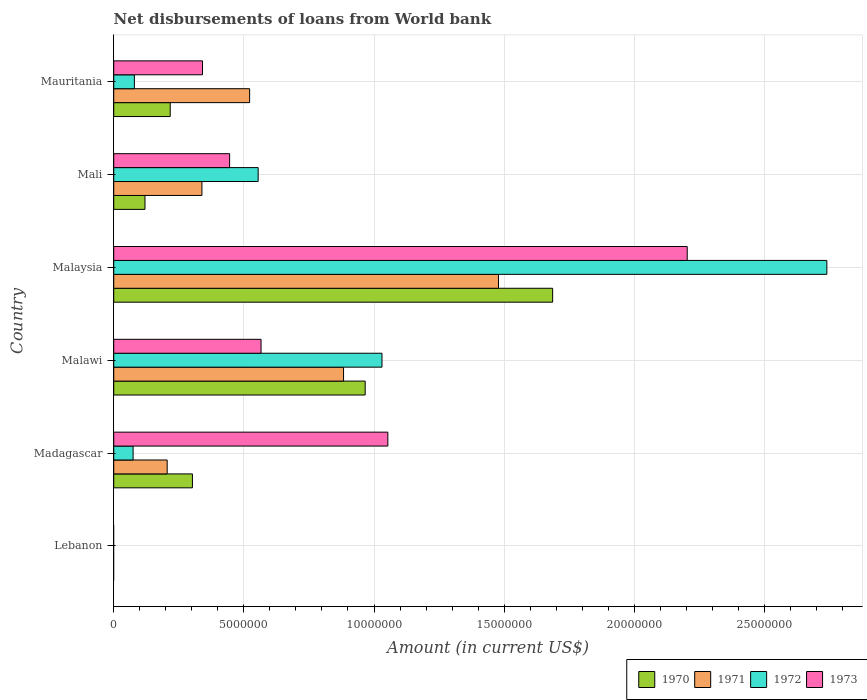How many different coloured bars are there?
Your answer should be compact. 4. What is the label of the 4th group of bars from the top?
Your response must be concise. Malawi. In how many cases, is the number of bars for a given country not equal to the number of legend labels?
Keep it short and to the point. 1. What is the amount of loan disbursed from World Bank in 1970 in Malaysia?
Make the answer very short. 1.69e+07. Across all countries, what is the maximum amount of loan disbursed from World Bank in 1972?
Give a very brief answer. 2.74e+07. In which country was the amount of loan disbursed from World Bank in 1973 maximum?
Give a very brief answer. Malaysia. What is the total amount of loan disbursed from World Bank in 1972 in the graph?
Give a very brief answer. 4.48e+07. What is the difference between the amount of loan disbursed from World Bank in 1971 in Malaysia and that in Mali?
Ensure brevity in your answer.  1.14e+07. What is the difference between the amount of loan disbursed from World Bank in 1973 in Malaysia and the amount of loan disbursed from World Bank in 1972 in Madagascar?
Offer a terse response. 2.13e+07. What is the average amount of loan disbursed from World Bank in 1971 per country?
Offer a very short reply. 5.71e+06. What is the difference between the amount of loan disbursed from World Bank in 1971 and amount of loan disbursed from World Bank in 1970 in Madagascar?
Make the answer very short. -9.70e+05. In how many countries, is the amount of loan disbursed from World Bank in 1973 greater than 4000000 US$?
Ensure brevity in your answer.  4. What is the ratio of the amount of loan disbursed from World Bank in 1970 in Malaysia to that in Mauritania?
Give a very brief answer. 7.77. Is the difference between the amount of loan disbursed from World Bank in 1971 in Madagascar and Mali greater than the difference between the amount of loan disbursed from World Bank in 1970 in Madagascar and Mali?
Give a very brief answer. No. What is the difference between the highest and the second highest amount of loan disbursed from World Bank in 1973?
Provide a succinct answer. 1.15e+07. What is the difference between the highest and the lowest amount of loan disbursed from World Bank in 1972?
Offer a terse response. 2.74e+07. Is it the case that in every country, the sum of the amount of loan disbursed from World Bank in 1970 and amount of loan disbursed from World Bank in 1971 is greater than the sum of amount of loan disbursed from World Bank in 1972 and amount of loan disbursed from World Bank in 1973?
Your response must be concise. No. What is the difference between two consecutive major ticks on the X-axis?
Your answer should be compact. 5.00e+06. Are the values on the major ticks of X-axis written in scientific E-notation?
Keep it short and to the point. No. How are the legend labels stacked?
Provide a succinct answer. Horizontal. What is the title of the graph?
Make the answer very short. Net disbursements of loans from World bank. What is the label or title of the X-axis?
Your answer should be very brief. Amount (in current US$). What is the Amount (in current US$) of 1971 in Lebanon?
Your answer should be compact. 0. What is the Amount (in current US$) of 1970 in Madagascar?
Provide a short and direct response. 3.02e+06. What is the Amount (in current US$) in 1971 in Madagascar?
Ensure brevity in your answer.  2.05e+06. What is the Amount (in current US$) in 1972 in Madagascar?
Offer a terse response. 7.44e+05. What is the Amount (in current US$) of 1973 in Madagascar?
Provide a short and direct response. 1.05e+07. What is the Amount (in current US$) of 1970 in Malawi?
Ensure brevity in your answer.  9.66e+06. What is the Amount (in current US$) of 1971 in Malawi?
Offer a terse response. 8.83e+06. What is the Amount (in current US$) of 1972 in Malawi?
Offer a very short reply. 1.03e+07. What is the Amount (in current US$) of 1973 in Malawi?
Keep it short and to the point. 5.66e+06. What is the Amount (in current US$) in 1970 in Malaysia?
Provide a short and direct response. 1.69e+07. What is the Amount (in current US$) of 1971 in Malaysia?
Keep it short and to the point. 1.48e+07. What is the Amount (in current US$) of 1972 in Malaysia?
Keep it short and to the point. 2.74e+07. What is the Amount (in current US$) of 1973 in Malaysia?
Ensure brevity in your answer.  2.20e+07. What is the Amount (in current US$) in 1970 in Mali?
Offer a very short reply. 1.20e+06. What is the Amount (in current US$) of 1971 in Mali?
Provide a short and direct response. 3.39e+06. What is the Amount (in current US$) of 1972 in Mali?
Give a very brief answer. 5.55e+06. What is the Amount (in current US$) of 1973 in Mali?
Offer a terse response. 4.45e+06. What is the Amount (in current US$) of 1970 in Mauritania?
Make the answer very short. 2.17e+06. What is the Amount (in current US$) of 1971 in Mauritania?
Provide a short and direct response. 5.22e+06. What is the Amount (in current US$) of 1972 in Mauritania?
Offer a very short reply. 7.93e+05. What is the Amount (in current US$) in 1973 in Mauritania?
Provide a succinct answer. 3.41e+06. Across all countries, what is the maximum Amount (in current US$) of 1970?
Offer a terse response. 1.69e+07. Across all countries, what is the maximum Amount (in current US$) in 1971?
Ensure brevity in your answer.  1.48e+07. Across all countries, what is the maximum Amount (in current US$) in 1972?
Your response must be concise. 2.74e+07. Across all countries, what is the maximum Amount (in current US$) of 1973?
Keep it short and to the point. 2.20e+07. Across all countries, what is the minimum Amount (in current US$) of 1971?
Make the answer very short. 0. Across all countries, what is the minimum Amount (in current US$) of 1972?
Your response must be concise. 0. Across all countries, what is the minimum Amount (in current US$) of 1973?
Your answer should be compact. 0. What is the total Amount (in current US$) in 1970 in the graph?
Offer a very short reply. 3.29e+07. What is the total Amount (in current US$) in 1971 in the graph?
Offer a very short reply. 3.43e+07. What is the total Amount (in current US$) of 1972 in the graph?
Keep it short and to the point. 4.48e+07. What is the total Amount (in current US$) in 1973 in the graph?
Offer a terse response. 4.61e+07. What is the difference between the Amount (in current US$) in 1970 in Madagascar and that in Malawi?
Your answer should be very brief. -6.64e+06. What is the difference between the Amount (in current US$) of 1971 in Madagascar and that in Malawi?
Ensure brevity in your answer.  -6.78e+06. What is the difference between the Amount (in current US$) of 1972 in Madagascar and that in Malawi?
Make the answer very short. -9.56e+06. What is the difference between the Amount (in current US$) in 1973 in Madagascar and that in Malawi?
Ensure brevity in your answer.  4.87e+06. What is the difference between the Amount (in current US$) in 1970 in Madagascar and that in Malaysia?
Provide a short and direct response. -1.38e+07. What is the difference between the Amount (in current US$) in 1971 in Madagascar and that in Malaysia?
Provide a succinct answer. -1.27e+07. What is the difference between the Amount (in current US$) of 1972 in Madagascar and that in Malaysia?
Provide a short and direct response. -2.67e+07. What is the difference between the Amount (in current US$) in 1973 in Madagascar and that in Malaysia?
Give a very brief answer. -1.15e+07. What is the difference between the Amount (in current US$) in 1970 in Madagascar and that in Mali?
Keep it short and to the point. 1.82e+06. What is the difference between the Amount (in current US$) of 1971 in Madagascar and that in Mali?
Give a very brief answer. -1.34e+06. What is the difference between the Amount (in current US$) of 1972 in Madagascar and that in Mali?
Ensure brevity in your answer.  -4.80e+06. What is the difference between the Amount (in current US$) of 1973 in Madagascar and that in Mali?
Keep it short and to the point. 6.08e+06. What is the difference between the Amount (in current US$) of 1970 in Madagascar and that in Mauritania?
Your answer should be very brief. 8.53e+05. What is the difference between the Amount (in current US$) of 1971 in Madagascar and that in Mauritania?
Ensure brevity in your answer.  -3.17e+06. What is the difference between the Amount (in current US$) in 1972 in Madagascar and that in Mauritania?
Your answer should be compact. -4.90e+04. What is the difference between the Amount (in current US$) of 1973 in Madagascar and that in Mauritania?
Offer a very short reply. 7.12e+06. What is the difference between the Amount (in current US$) of 1970 in Malawi and that in Malaysia?
Your response must be concise. -7.20e+06. What is the difference between the Amount (in current US$) in 1971 in Malawi and that in Malaysia?
Keep it short and to the point. -5.95e+06. What is the difference between the Amount (in current US$) of 1972 in Malawi and that in Malaysia?
Offer a very short reply. -1.71e+07. What is the difference between the Amount (in current US$) in 1973 in Malawi and that in Malaysia?
Keep it short and to the point. -1.64e+07. What is the difference between the Amount (in current US$) in 1970 in Malawi and that in Mali?
Keep it short and to the point. 8.46e+06. What is the difference between the Amount (in current US$) of 1971 in Malawi and that in Mali?
Make the answer very short. 5.44e+06. What is the difference between the Amount (in current US$) of 1972 in Malawi and that in Mali?
Offer a very short reply. 4.76e+06. What is the difference between the Amount (in current US$) in 1973 in Malawi and that in Mali?
Ensure brevity in your answer.  1.21e+06. What is the difference between the Amount (in current US$) of 1970 in Malawi and that in Mauritania?
Your answer should be compact. 7.49e+06. What is the difference between the Amount (in current US$) in 1971 in Malawi and that in Mauritania?
Provide a short and direct response. 3.61e+06. What is the difference between the Amount (in current US$) in 1972 in Malawi and that in Mauritania?
Ensure brevity in your answer.  9.51e+06. What is the difference between the Amount (in current US$) in 1973 in Malawi and that in Mauritania?
Your answer should be compact. 2.25e+06. What is the difference between the Amount (in current US$) in 1970 in Malaysia and that in Mali?
Ensure brevity in your answer.  1.57e+07. What is the difference between the Amount (in current US$) of 1971 in Malaysia and that in Mali?
Make the answer very short. 1.14e+07. What is the difference between the Amount (in current US$) of 1972 in Malaysia and that in Mali?
Your answer should be compact. 2.19e+07. What is the difference between the Amount (in current US$) of 1973 in Malaysia and that in Mali?
Your response must be concise. 1.76e+07. What is the difference between the Amount (in current US$) in 1970 in Malaysia and that in Mauritania?
Ensure brevity in your answer.  1.47e+07. What is the difference between the Amount (in current US$) of 1971 in Malaysia and that in Mauritania?
Ensure brevity in your answer.  9.56e+06. What is the difference between the Amount (in current US$) of 1972 in Malaysia and that in Mauritania?
Provide a short and direct response. 2.66e+07. What is the difference between the Amount (in current US$) in 1973 in Malaysia and that in Mauritania?
Give a very brief answer. 1.86e+07. What is the difference between the Amount (in current US$) in 1970 in Mali and that in Mauritania?
Ensure brevity in your answer.  -9.70e+05. What is the difference between the Amount (in current US$) in 1971 in Mali and that in Mauritania?
Ensure brevity in your answer.  -1.83e+06. What is the difference between the Amount (in current US$) of 1972 in Mali and that in Mauritania?
Provide a short and direct response. 4.76e+06. What is the difference between the Amount (in current US$) of 1973 in Mali and that in Mauritania?
Make the answer very short. 1.04e+06. What is the difference between the Amount (in current US$) of 1970 in Madagascar and the Amount (in current US$) of 1971 in Malawi?
Offer a very short reply. -5.81e+06. What is the difference between the Amount (in current US$) in 1970 in Madagascar and the Amount (in current US$) in 1972 in Malawi?
Your answer should be compact. -7.28e+06. What is the difference between the Amount (in current US$) in 1970 in Madagascar and the Amount (in current US$) in 1973 in Malawi?
Give a very brief answer. -2.64e+06. What is the difference between the Amount (in current US$) in 1971 in Madagascar and the Amount (in current US$) in 1972 in Malawi?
Make the answer very short. -8.25e+06. What is the difference between the Amount (in current US$) of 1971 in Madagascar and the Amount (in current US$) of 1973 in Malawi?
Offer a very short reply. -3.61e+06. What is the difference between the Amount (in current US$) in 1972 in Madagascar and the Amount (in current US$) in 1973 in Malawi?
Give a very brief answer. -4.92e+06. What is the difference between the Amount (in current US$) of 1970 in Madagascar and the Amount (in current US$) of 1971 in Malaysia?
Provide a short and direct response. -1.18e+07. What is the difference between the Amount (in current US$) of 1970 in Madagascar and the Amount (in current US$) of 1972 in Malaysia?
Keep it short and to the point. -2.44e+07. What is the difference between the Amount (in current US$) in 1970 in Madagascar and the Amount (in current US$) in 1973 in Malaysia?
Your answer should be very brief. -1.90e+07. What is the difference between the Amount (in current US$) of 1971 in Madagascar and the Amount (in current US$) of 1972 in Malaysia?
Provide a succinct answer. -2.53e+07. What is the difference between the Amount (in current US$) of 1971 in Madagascar and the Amount (in current US$) of 1973 in Malaysia?
Make the answer very short. -2.00e+07. What is the difference between the Amount (in current US$) in 1972 in Madagascar and the Amount (in current US$) in 1973 in Malaysia?
Your answer should be very brief. -2.13e+07. What is the difference between the Amount (in current US$) in 1970 in Madagascar and the Amount (in current US$) in 1971 in Mali?
Provide a short and direct response. -3.65e+05. What is the difference between the Amount (in current US$) of 1970 in Madagascar and the Amount (in current US$) of 1972 in Mali?
Offer a very short reply. -2.53e+06. What is the difference between the Amount (in current US$) in 1970 in Madagascar and the Amount (in current US$) in 1973 in Mali?
Give a very brief answer. -1.43e+06. What is the difference between the Amount (in current US$) of 1971 in Madagascar and the Amount (in current US$) of 1972 in Mali?
Your response must be concise. -3.50e+06. What is the difference between the Amount (in current US$) in 1971 in Madagascar and the Amount (in current US$) in 1973 in Mali?
Provide a succinct answer. -2.40e+06. What is the difference between the Amount (in current US$) of 1972 in Madagascar and the Amount (in current US$) of 1973 in Mali?
Give a very brief answer. -3.71e+06. What is the difference between the Amount (in current US$) in 1970 in Madagascar and the Amount (in current US$) in 1971 in Mauritania?
Your response must be concise. -2.20e+06. What is the difference between the Amount (in current US$) in 1970 in Madagascar and the Amount (in current US$) in 1972 in Mauritania?
Your response must be concise. 2.23e+06. What is the difference between the Amount (in current US$) in 1970 in Madagascar and the Amount (in current US$) in 1973 in Mauritania?
Give a very brief answer. -3.88e+05. What is the difference between the Amount (in current US$) in 1971 in Madagascar and the Amount (in current US$) in 1972 in Mauritania?
Give a very brief answer. 1.26e+06. What is the difference between the Amount (in current US$) of 1971 in Madagascar and the Amount (in current US$) of 1973 in Mauritania?
Your answer should be very brief. -1.36e+06. What is the difference between the Amount (in current US$) in 1972 in Madagascar and the Amount (in current US$) in 1973 in Mauritania?
Provide a short and direct response. -2.67e+06. What is the difference between the Amount (in current US$) of 1970 in Malawi and the Amount (in current US$) of 1971 in Malaysia?
Ensure brevity in your answer.  -5.12e+06. What is the difference between the Amount (in current US$) in 1970 in Malawi and the Amount (in current US$) in 1972 in Malaysia?
Offer a very short reply. -1.77e+07. What is the difference between the Amount (in current US$) in 1970 in Malawi and the Amount (in current US$) in 1973 in Malaysia?
Give a very brief answer. -1.24e+07. What is the difference between the Amount (in current US$) of 1971 in Malawi and the Amount (in current US$) of 1972 in Malaysia?
Offer a very short reply. -1.86e+07. What is the difference between the Amount (in current US$) in 1971 in Malawi and the Amount (in current US$) in 1973 in Malaysia?
Your response must be concise. -1.32e+07. What is the difference between the Amount (in current US$) of 1972 in Malawi and the Amount (in current US$) of 1973 in Malaysia?
Make the answer very short. -1.17e+07. What is the difference between the Amount (in current US$) of 1970 in Malawi and the Amount (in current US$) of 1971 in Mali?
Offer a very short reply. 6.27e+06. What is the difference between the Amount (in current US$) in 1970 in Malawi and the Amount (in current US$) in 1972 in Mali?
Keep it short and to the point. 4.11e+06. What is the difference between the Amount (in current US$) of 1970 in Malawi and the Amount (in current US$) of 1973 in Mali?
Your answer should be compact. 5.21e+06. What is the difference between the Amount (in current US$) in 1971 in Malawi and the Amount (in current US$) in 1972 in Mali?
Ensure brevity in your answer.  3.28e+06. What is the difference between the Amount (in current US$) in 1971 in Malawi and the Amount (in current US$) in 1973 in Mali?
Provide a short and direct response. 4.38e+06. What is the difference between the Amount (in current US$) of 1972 in Malawi and the Amount (in current US$) of 1973 in Mali?
Offer a terse response. 5.86e+06. What is the difference between the Amount (in current US$) of 1970 in Malawi and the Amount (in current US$) of 1971 in Mauritania?
Your response must be concise. 4.44e+06. What is the difference between the Amount (in current US$) of 1970 in Malawi and the Amount (in current US$) of 1972 in Mauritania?
Your answer should be very brief. 8.87e+06. What is the difference between the Amount (in current US$) in 1970 in Malawi and the Amount (in current US$) in 1973 in Mauritania?
Ensure brevity in your answer.  6.25e+06. What is the difference between the Amount (in current US$) of 1971 in Malawi and the Amount (in current US$) of 1972 in Mauritania?
Your response must be concise. 8.04e+06. What is the difference between the Amount (in current US$) in 1971 in Malawi and the Amount (in current US$) in 1973 in Mauritania?
Your response must be concise. 5.42e+06. What is the difference between the Amount (in current US$) of 1972 in Malawi and the Amount (in current US$) of 1973 in Mauritania?
Your response must be concise. 6.90e+06. What is the difference between the Amount (in current US$) of 1970 in Malaysia and the Amount (in current US$) of 1971 in Mali?
Make the answer very short. 1.35e+07. What is the difference between the Amount (in current US$) of 1970 in Malaysia and the Amount (in current US$) of 1972 in Mali?
Provide a succinct answer. 1.13e+07. What is the difference between the Amount (in current US$) of 1970 in Malaysia and the Amount (in current US$) of 1973 in Mali?
Keep it short and to the point. 1.24e+07. What is the difference between the Amount (in current US$) in 1971 in Malaysia and the Amount (in current US$) in 1972 in Mali?
Your answer should be compact. 9.24e+06. What is the difference between the Amount (in current US$) in 1971 in Malaysia and the Amount (in current US$) in 1973 in Mali?
Provide a short and direct response. 1.03e+07. What is the difference between the Amount (in current US$) in 1972 in Malaysia and the Amount (in current US$) in 1973 in Mali?
Your response must be concise. 2.29e+07. What is the difference between the Amount (in current US$) in 1970 in Malaysia and the Amount (in current US$) in 1971 in Mauritania?
Your answer should be very brief. 1.16e+07. What is the difference between the Amount (in current US$) in 1970 in Malaysia and the Amount (in current US$) in 1972 in Mauritania?
Give a very brief answer. 1.61e+07. What is the difference between the Amount (in current US$) of 1970 in Malaysia and the Amount (in current US$) of 1973 in Mauritania?
Offer a very short reply. 1.35e+07. What is the difference between the Amount (in current US$) in 1971 in Malaysia and the Amount (in current US$) in 1972 in Mauritania?
Your response must be concise. 1.40e+07. What is the difference between the Amount (in current US$) of 1971 in Malaysia and the Amount (in current US$) of 1973 in Mauritania?
Give a very brief answer. 1.14e+07. What is the difference between the Amount (in current US$) in 1972 in Malaysia and the Amount (in current US$) in 1973 in Mauritania?
Give a very brief answer. 2.40e+07. What is the difference between the Amount (in current US$) of 1970 in Mali and the Amount (in current US$) of 1971 in Mauritania?
Your answer should be compact. -4.02e+06. What is the difference between the Amount (in current US$) in 1970 in Mali and the Amount (in current US$) in 1972 in Mauritania?
Give a very brief answer. 4.07e+05. What is the difference between the Amount (in current US$) in 1970 in Mali and the Amount (in current US$) in 1973 in Mauritania?
Your response must be concise. -2.21e+06. What is the difference between the Amount (in current US$) in 1971 in Mali and the Amount (in current US$) in 1972 in Mauritania?
Your answer should be compact. 2.60e+06. What is the difference between the Amount (in current US$) of 1971 in Mali and the Amount (in current US$) of 1973 in Mauritania?
Ensure brevity in your answer.  -2.30e+04. What is the difference between the Amount (in current US$) in 1972 in Mali and the Amount (in current US$) in 1973 in Mauritania?
Ensure brevity in your answer.  2.14e+06. What is the average Amount (in current US$) of 1970 per country?
Your answer should be compact. 5.49e+06. What is the average Amount (in current US$) of 1971 per country?
Provide a succinct answer. 5.71e+06. What is the average Amount (in current US$) in 1972 per country?
Ensure brevity in your answer.  7.47e+06. What is the average Amount (in current US$) in 1973 per country?
Offer a terse response. 7.68e+06. What is the difference between the Amount (in current US$) in 1970 and Amount (in current US$) in 1971 in Madagascar?
Make the answer very short. 9.70e+05. What is the difference between the Amount (in current US$) in 1970 and Amount (in current US$) in 1972 in Madagascar?
Provide a short and direct response. 2.28e+06. What is the difference between the Amount (in current US$) in 1970 and Amount (in current US$) in 1973 in Madagascar?
Provide a short and direct response. -7.51e+06. What is the difference between the Amount (in current US$) in 1971 and Amount (in current US$) in 1972 in Madagascar?
Provide a short and direct response. 1.31e+06. What is the difference between the Amount (in current US$) of 1971 and Amount (in current US$) of 1973 in Madagascar?
Your answer should be compact. -8.48e+06. What is the difference between the Amount (in current US$) of 1972 and Amount (in current US$) of 1973 in Madagascar?
Keep it short and to the point. -9.79e+06. What is the difference between the Amount (in current US$) of 1970 and Amount (in current US$) of 1971 in Malawi?
Ensure brevity in your answer.  8.31e+05. What is the difference between the Amount (in current US$) in 1970 and Amount (in current US$) in 1972 in Malawi?
Ensure brevity in your answer.  -6.46e+05. What is the difference between the Amount (in current US$) in 1970 and Amount (in current US$) in 1973 in Malawi?
Ensure brevity in your answer.  4.00e+06. What is the difference between the Amount (in current US$) of 1971 and Amount (in current US$) of 1972 in Malawi?
Offer a terse response. -1.48e+06. What is the difference between the Amount (in current US$) in 1971 and Amount (in current US$) in 1973 in Malawi?
Offer a very short reply. 3.17e+06. What is the difference between the Amount (in current US$) in 1972 and Amount (in current US$) in 1973 in Malawi?
Keep it short and to the point. 4.65e+06. What is the difference between the Amount (in current US$) of 1970 and Amount (in current US$) of 1971 in Malaysia?
Your answer should be very brief. 2.08e+06. What is the difference between the Amount (in current US$) in 1970 and Amount (in current US$) in 1972 in Malaysia?
Offer a terse response. -1.05e+07. What is the difference between the Amount (in current US$) of 1970 and Amount (in current US$) of 1973 in Malaysia?
Make the answer very short. -5.17e+06. What is the difference between the Amount (in current US$) in 1971 and Amount (in current US$) in 1972 in Malaysia?
Offer a terse response. -1.26e+07. What is the difference between the Amount (in current US$) in 1971 and Amount (in current US$) in 1973 in Malaysia?
Offer a very short reply. -7.25e+06. What is the difference between the Amount (in current US$) of 1972 and Amount (in current US$) of 1973 in Malaysia?
Provide a short and direct response. 5.36e+06. What is the difference between the Amount (in current US$) of 1970 and Amount (in current US$) of 1971 in Mali?
Offer a very short reply. -2.19e+06. What is the difference between the Amount (in current US$) in 1970 and Amount (in current US$) in 1972 in Mali?
Ensure brevity in your answer.  -4.35e+06. What is the difference between the Amount (in current US$) of 1970 and Amount (in current US$) of 1973 in Mali?
Keep it short and to the point. -3.25e+06. What is the difference between the Amount (in current US$) of 1971 and Amount (in current US$) of 1972 in Mali?
Provide a short and direct response. -2.16e+06. What is the difference between the Amount (in current US$) of 1971 and Amount (in current US$) of 1973 in Mali?
Provide a short and direct response. -1.06e+06. What is the difference between the Amount (in current US$) of 1972 and Amount (in current US$) of 1973 in Mali?
Keep it short and to the point. 1.10e+06. What is the difference between the Amount (in current US$) in 1970 and Amount (in current US$) in 1971 in Mauritania?
Keep it short and to the point. -3.05e+06. What is the difference between the Amount (in current US$) in 1970 and Amount (in current US$) in 1972 in Mauritania?
Offer a terse response. 1.38e+06. What is the difference between the Amount (in current US$) in 1970 and Amount (in current US$) in 1973 in Mauritania?
Make the answer very short. -1.24e+06. What is the difference between the Amount (in current US$) of 1971 and Amount (in current US$) of 1972 in Mauritania?
Offer a terse response. 4.43e+06. What is the difference between the Amount (in current US$) of 1971 and Amount (in current US$) of 1973 in Mauritania?
Your answer should be compact. 1.81e+06. What is the difference between the Amount (in current US$) of 1972 and Amount (in current US$) of 1973 in Mauritania?
Offer a terse response. -2.62e+06. What is the ratio of the Amount (in current US$) in 1970 in Madagascar to that in Malawi?
Give a very brief answer. 0.31. What is the ratio of the Amount (in current US$) in 1971 in Madagascar to that in Malawi?
Offer a very short reply. 0.23. What is the ratio of the Amount (in current US$) in 1972 in Madagascar to that in Malawi?
Provide a succinct answer. 0.07. What is the ratio of the Amount (in current US$) of 1973 in Madagascar to that in Malawi?
Provide a succinct answer. 1.86. What is the ratio of the Amount (in current US$) in 1970 in Madagascar to that in Malaysia?
Your answer should be very brief. 0.18. What is the ratio of the Amount (in current US$) of 1971 in Madagascar to that in Malaysia?
Give a very brief answer. 0.14. What is the ratio of the Amount (in current US$) in 1972 in Madagascar to that in Malaysia?
Your answer should be very brief. 0.03. What is the ratio of the Amount (in current US$) of 1973 in Madagascar to that in Malaysia?
Provide a succinct answer. 0.48. What is the ratio of the Amount (in current US$) in 1970 in Madagascar to that in Mali?
Your answer should be very brief. 2.52. What is the ratio of the Amount (in current US$) in 1971 in Madagascar to that in Mali?
Offer a terse response. 0.61. What is the ratio of the Amount (in current US$) of 1972 in Madagascar to that in Mali?
Keep it short and to the point. 0.13. What is the ratio of the Amount (in current US$) in 1973 in Madagascar to that in Mali?
Provide a short and direct response. 2.37. What is the ratio of the Amount (in current US$) of 1970 in Madagascar to that in Mauritania?
Your response must be concise. 1.39. What is the ratio of the Amount (in current US$) in 1971 in Madagascar to that in Mauritania?
Offer a terse response. 0.39. What is the ratio of the Amount (in current US$) in 1972 in Madagascar to that in Mauritania?
Offer a very short reply. 0.94. What is the ratio of the Amount (in current US$) of 1973 in Madagascar to that in Mauritania?
Keep it short and to the point. 3.09. What is the ratio of the Amount (in current US$) of 1970 in Malawi to that in Malaysia?
Your answer should be compact. 0.57. What is the ratio of the Amount (in current US$) in 1971 in Malawi to that in Malaysia?
Your response must be concise. 0.6. What is the ratio of the Amount (in current US$) in 1972 in Malawi to that in Malaysia?
Offer a very short reply. 0.38. What is the ratio of the Amount (in current US$) of 1973 in Malawi to that in Malaysia?
Ensure brevity in your answer.  0.26. What is the ratio of the Amount (in current US$) of 1970 in Malawi to that in Mali?
Give a very brief answer. 8.05. What is the ratio of the Amount (in current US$) in 1971 in Malawi to that in Mali?
Make the answer very short. 2.61. What is the ratio of the Amount (in current US$) in 1972 in Malawi to that in Mali?
Your response must be concise. 1.86. What is the ratio of the Amount (in current US$) in 1973 in Malawi to that in Mali?
Make the answer very short. 1.27. What is the ratio of the Amount (in current US$) in 1970 in Malawi to that in Mauritania?
Your response must be concise. 4.45. What is the ratio of the Amount (in current US$) in 1971 in Malawi to that in Mauritania?
Give a very brief answer. 1.69. What is the ratio of the Amount (in current US$) of 1972 in Malawi to that in Mauritania?
Your response must be concise. 13. What is the ratio of the Amount (in current US$) of 1973 in Malawi to that in Mauritania?
Provide a short and direct response. 1.66. What is the ratio of the Amount (in current US$) of 1970 in Malaysia to that in Mali?
Offer a very short reply. 14.05. What is the ratio of the Amount (in current US$) in 1971 in Malaysia to that in Mali?
Your answer should be compact. 4.36. What is the ratio of the Amount (in current US$) of 1972 in Malaysia to that in Mali?
Keep it short and to the point. 4.94. What is the ratio of the Amount (in current US$) of 1973 in Malaysia to that in Mali?
Provide a short and direct response. 4.95. What is the ratio of the Amount (in current US$) of 1970 in Malaysia to that in Mauritania?
Provide a short and direct response. 7.77. What is the ratio of the Amount (in current US$) in 1971 in Malaysia to that in Mauritania?
Your answer should be compact. 2.83. What is the ratio of the Amount (in current US$) in 1972 in Malaysia to that in Mauritania?
Make the answer very short. 34.55. What is the ratio of the Amount (in current US$) in 1973 in Malaysia to that in Mauritania?
Make the answer very short. 6.46. What is the ratio of the Amount (in current US$) of 1970 in Mali to that in Mauritania?
Your answer should be compact. 0.55. What is the ratio of the Amount (in current US$) of 1971 in Mali to that in Mauritania?
Your response must be concise. 0.65. What is the ratio of the Amount (in current US$) in 1972 in Mali to that in Mauritania?
Keep it short and to the point. 7. What is the ratio of the Amount (in current US$) in 1973 in Mali to that in Mauritania?
Your answer should be very brief. 1.31. What is the difference between the highest and the second highest Amount (in current US$) of 1970?
Provide a short and direct response. 7.20e+06. What is the difference between the highest and the second highest Amount (in current US$) of 1971?
Your answer should be compact. 5.95e+06. What is the difference between the highest and the second highest Amount (in current US$) of 1972?
Offer a very short reply. 1.71e+07. What is the difference between the highest and the second highest Amount (in current US$) in 1973?
Your answer should be very brief. 1.15e+07. What is the difference between the highest and the lowest Amount (in current US$) in 1970?
Your response must be concise. 1.69e+07. What is the difference between the highest and the lowest Amount (in current US$) in 1971?
Give a very brief answer. 1.48e+07. What is the difference between the highest and the lowest Amount (in current US$) in 1972?
Make the answer very short. 2.74e+07. What is the difference between the highest and the lowest Amount (in current US$) in 1973?
Provide a succinct answer. 2.20e+07. 